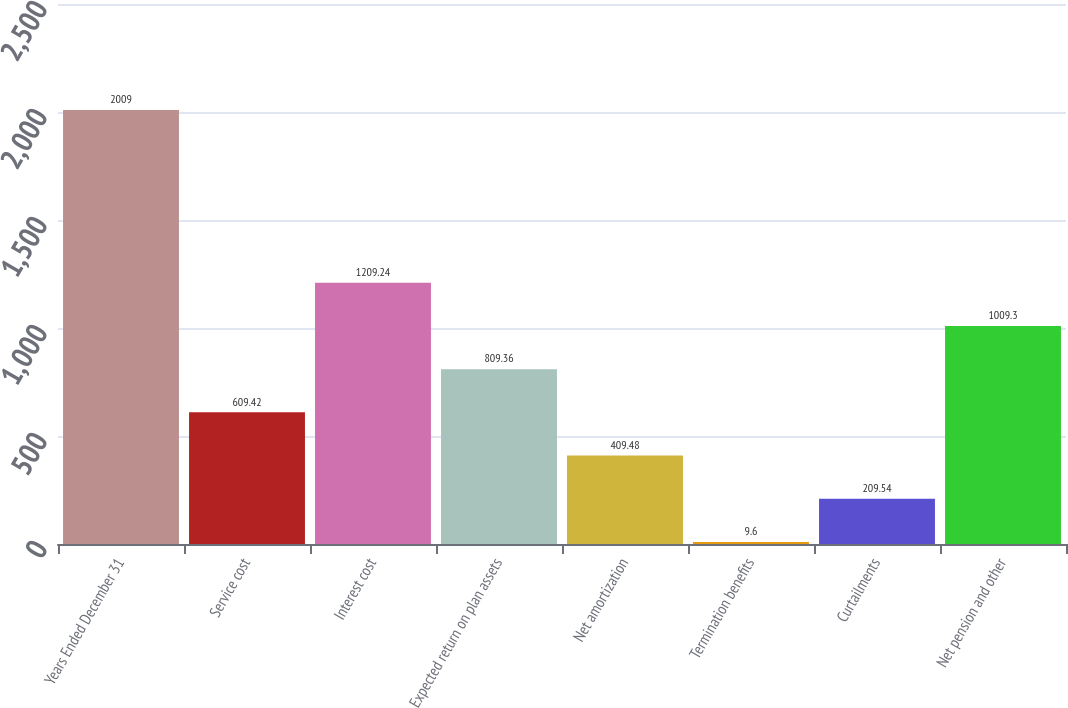Convert chart to OTSL. <chart><loc_0><loc_0><loc_500><loc_500><bar_chart><fcel>Years Ended December 31<fcel>Service cost<fcel>Interest cost<fcel>Expected return on plan assets<fcel>Net amortization<fcel>Termination benefits<fcel>Curtailments<fcel>Net pension and other<nl><fcel>2009<fcel>609.42<fcel>1209.24<fcel>809.36<fcel>409.48<fcel>9.6<fcel>209.54<fcel>1009.3<nl></chart> 